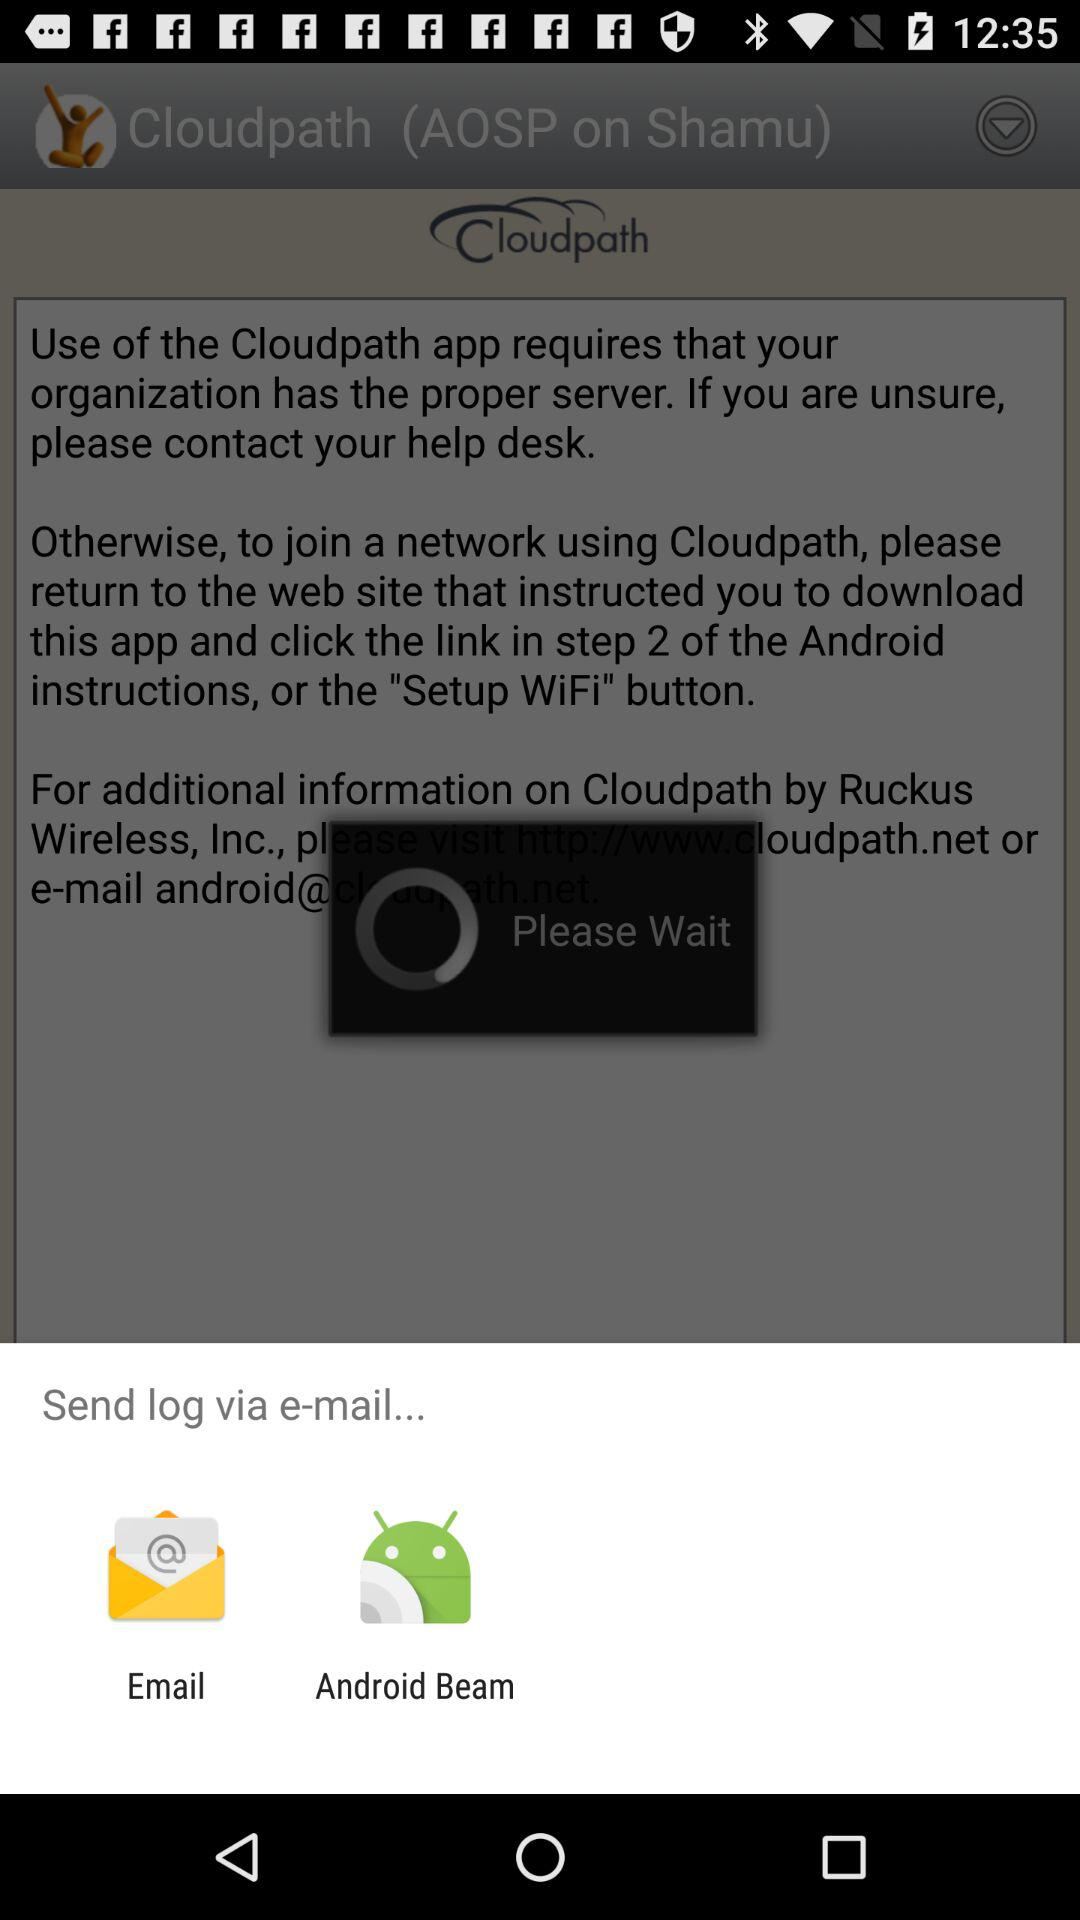What options are given for sending the log? The options given are "Email" and "Android Beam". 